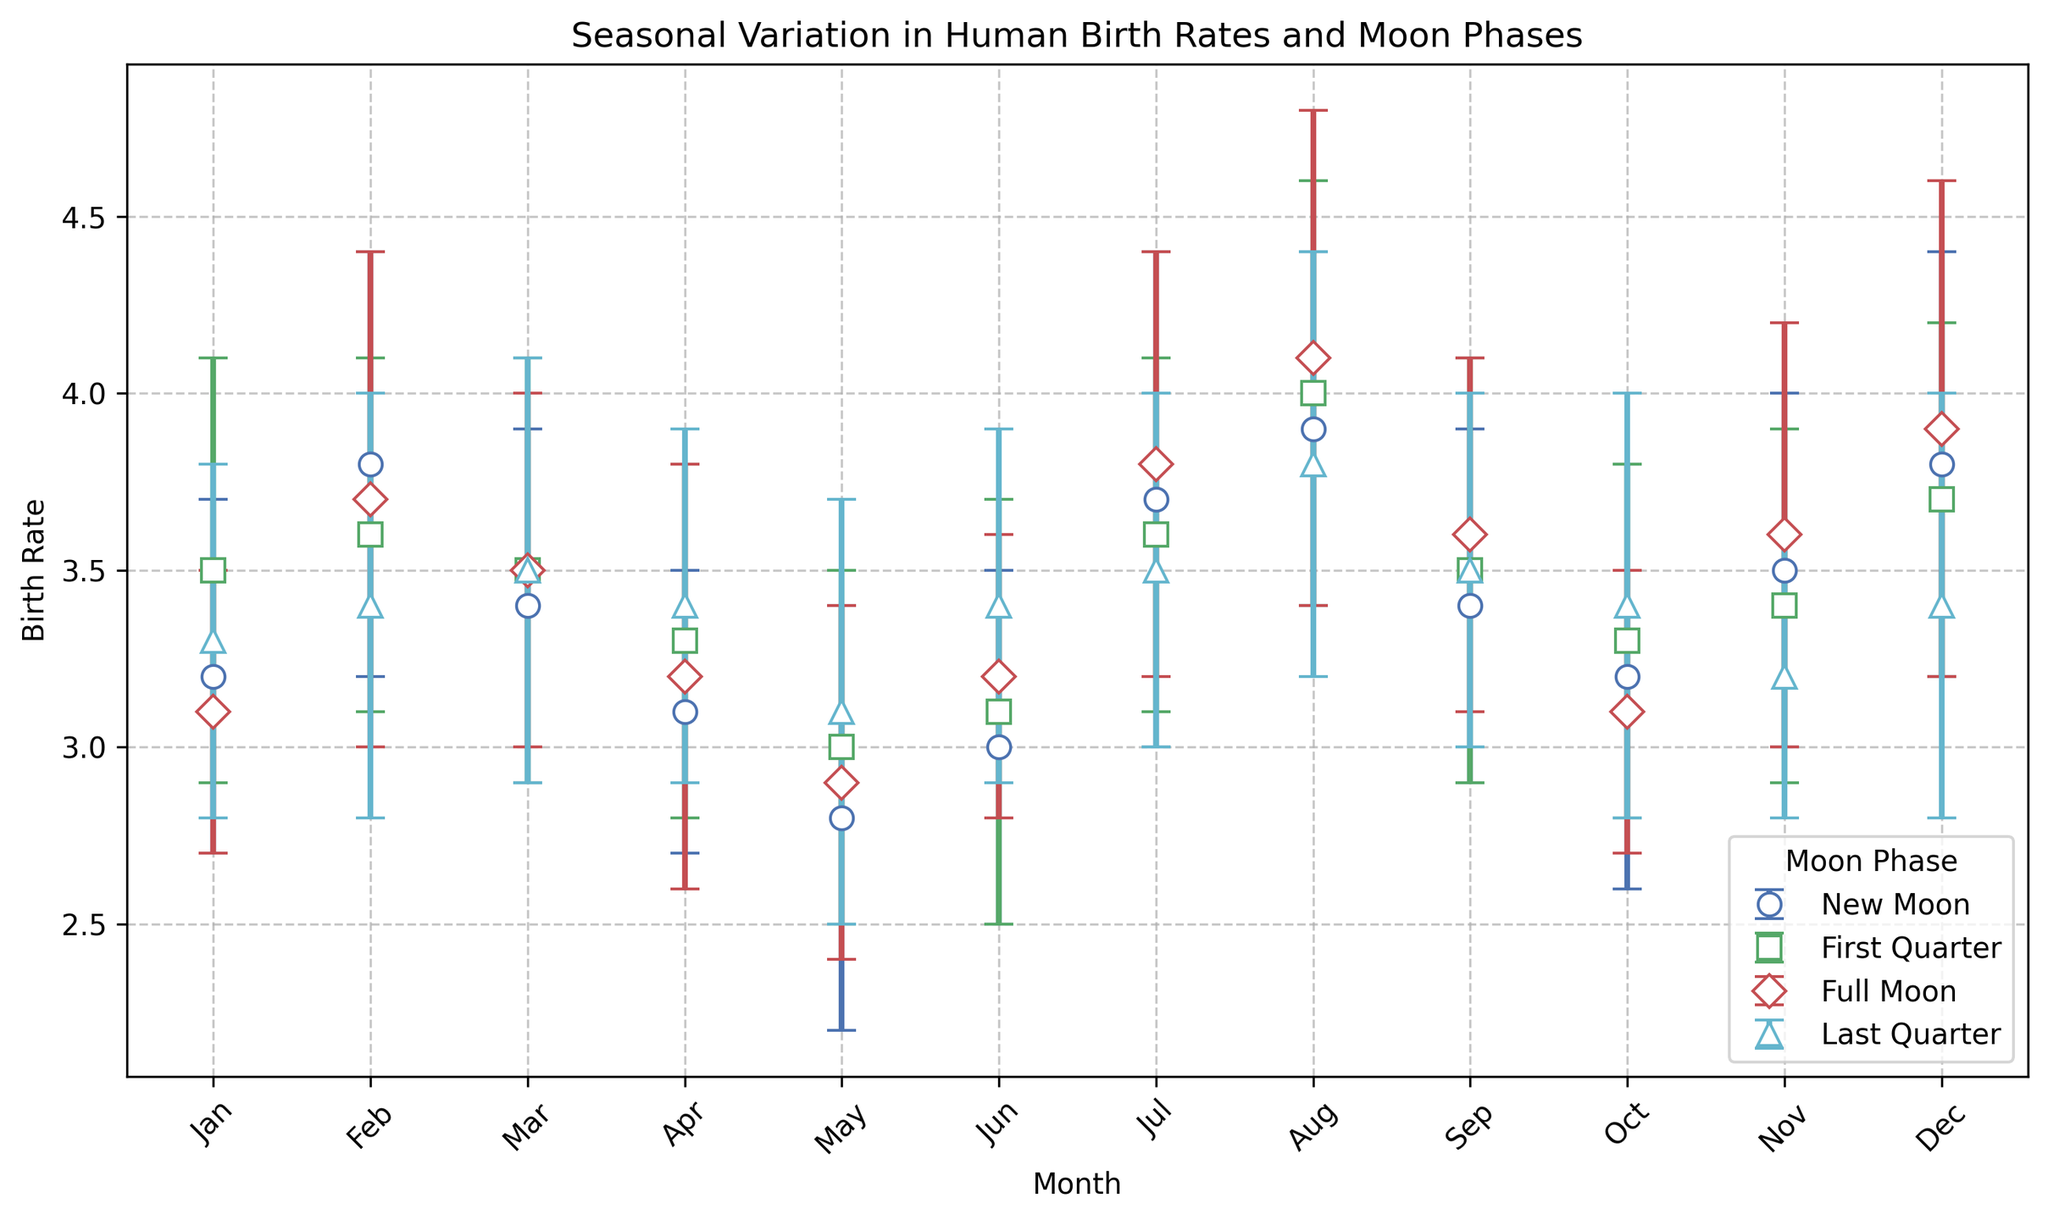What is the average birth rate in January across all moon phases? To find the average birth rate in January, sum the birth rates for January across all moon phases (New Moon, First Quarter, Full Moon, Last Quarter) and divide by the number of data points. The values are 3.2, 3.5, 3.1, and 3.3 respectively. Sum = 3.2 + 3.5 + 3.1 + 3.3 = 13.1. Average = 13.1 / 4 = 3.275
Answer: 3.275 During which month does the Full Moon phase have the highest birth rate compared to other phases? Compare birth rates of all moon phases for each month. For July, Full Moon has a birth rate of 3.8, which is higher than New Moon (3.7), First Quarter (3.6) and Last Quarter (3.5). Also, for August, Full Moon has 4.1, higher than 3.9 (New Moon), 4.0 (First Quarter), and 3.8 (Last Quarter). Comparing July and August values, in August Full Moon has the highest birth rate.
Answer: August Which month has the highest average birth rate across all moon phases? Find the average birth rate for each month by summing the birth rates of all Moon Phases of each month and dividing by 4. The highest average is found for August. (New Moon: 3.9, First Quarter: 4.0, Full Moon: 4.1, Last Quarter: 3.8). Average = (3.9+4.0+4.1+3.8)/4 = 3.95
Answer: August Does the Last Quarter phase consistently have lower birth rates compared to the Full Moon phase? Compare birth rates of Last Quarter and Full Moon phases across all months. For more months, Last Quarter phase birth rates are lower than Full Moon, but exceptions exist in January (3.3 vs 3.1), April (3.4 vs 3.2), and Nov (3.2 vs 3.6). While generally lower, it is not consistent.
Answer: No Is there a month where all moon phases have almost the same birth rate? Look for months with minimal variance between birth rates across moon phases. March has identical or near-identical birth rates for New Moon (3.4), First Quarter (3.5), Full Moon (3.5), and Last Quarter (3.5).
Answer: March Which moon phase has the least variability in birth rates across months, as observed from the error bars? Smaller error bars indicate less variability. Comparing the error bars visually, the Full Moon phase consistently shows smaller error bars, especially noted in months like January and June, compared to other phases like New Moon or First Quarter.
Answer: Full Moon In which month is the average birth rate for the New Moon phase highest? Identify the monthly birth rates for the New Moon phase and find the highest value. The highest birth rate for New Moon is in August with a value of 3.9.
Answer: August Comparing July and December, which month has a greater standard deviation in birth rates for the Full Moon phase? Compare the standard deviations. July Full Moon has a standard deviation of 0.6, whereas December Full Moon has a standard deviation of 0.7. Therefore, December has a greater standard deviation.
Answer: December 